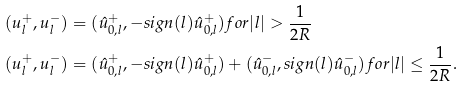<formula> <loc_0><loc_0><loc_500><loc_500>( u ^ { + } _ { l } , u ^ { - } _ { l } ) & = ( \hat { u } ^ { + } _ { 0 , l } , - s i g n ( l ) \hat { u } ^ { + } _ { 0 , l } ) f o r | l | > \frac { 1 } { 2 R } \\ ( u ^ { + } _ { l } , u ^ { - } _ { l } ) & = ( \hat { u } ^ { + } _ { 0 , l } , - s i g n ( l ) \hat { u } ^ { + } _ { 0 , l } ) + ( \hat { u } ^ { - } _ { 0 , l } , s i g n ( l ) \hat { u } ^ { - } _ { 0 , l } ) f o r | l | \leq \frac { 1 } { 2 R } .</formula> 